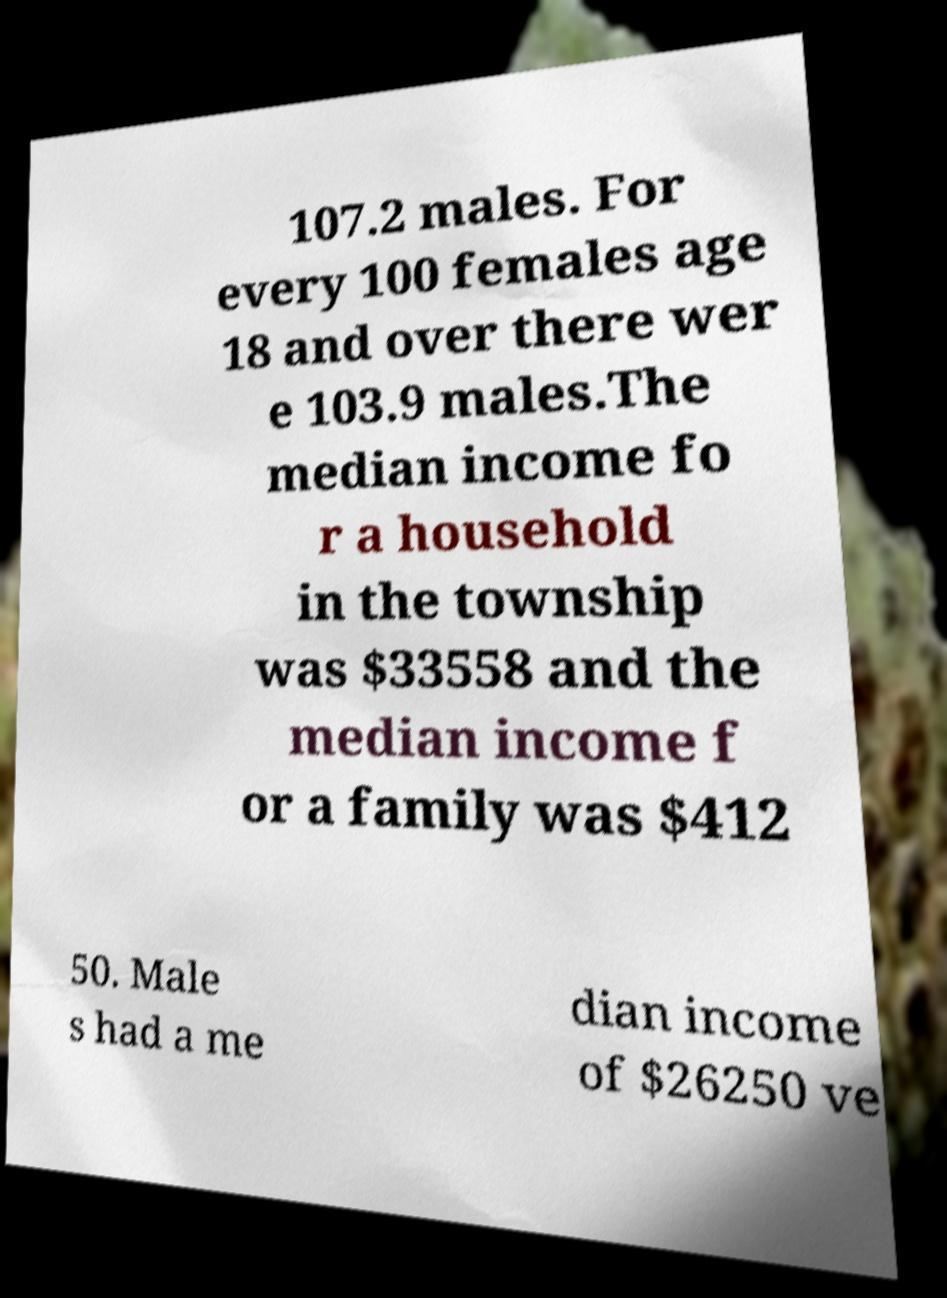What messages or text are displayed in this image? I need them in a readable, typed format. 107.2 males. For every 100 females age 18 and over there wer e 103.9 males.The median income fo r a household in the township was $33558 and the median income f or a family was $412 50. Male s had a me dian income of $26250 ve 